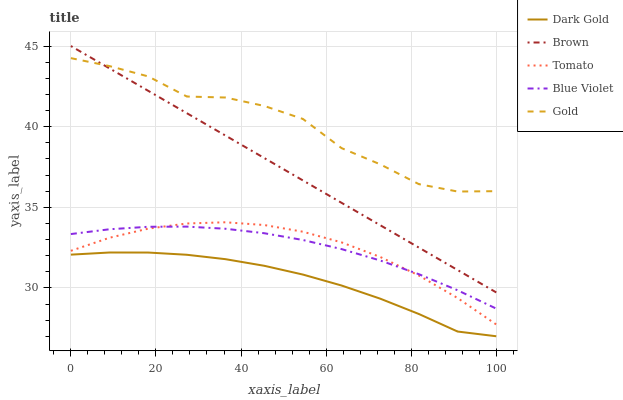Does Dark Gold have the minimum area under the curve?
Answer yes or no. Yes. Does Gold have the maximum area under the curve?
Answer yes or no. Yes. Does Brown have the minimum area under the curve?
Answer yes or no. No. Does Brown have the maximum area under the curve?
Answer yes or no. No. Is Brown the smoothest?
Answer yes or no. Yes. Is Gold the roughest?
Answer yes or no. Yes. Is Gold the smoothest?
Answer yes or no. No. Is Brown the roughest?
Answer yes or no. No. Does Dark Gold have the lowest value?
Answer yes or no. Yes. Does Brown have the lowest value?
Answer yes or no. No. Does Brown have the highest value?
Answer yes or no. Yes. Does Gold have the highest value?
Answer yes or no. No. Is Blue Violet less than Gold?
Answer yes or no. Yes. Is Gold greater than Tomato?
Answer yes or no. Yes. Does Gold intersect Brown?
Answer yes or no. Yes. Is Gold less than Brown?
Answer yes or no. No. Is Gold greater than Brown?
Answer yes or no. No. Does Blue Violet intersect Gold?
Answer yes or no. No. 